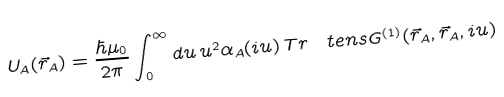Convert formula to latex. <formula><loc_0><loc_0><loc_500><loc_500>U _ { A } ( \vec { r } _ { A } ) = \frac { \hbar { \mu } _ { 0 } } { 2 \pi } \int _ { 0 } ^ { \infty } d u \, u ^ { 2 } \alpha _ { A } ( i u ) \, T r \, \ t e n s { G } ^ { ( 1 ) } ( \vec { r } _ { A } , \vec { r } _ { A } , i u )</formula> 